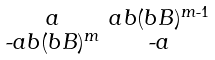<formula> <loc_0><loc_0><loc_500><loc_500>\begin{smallmatrix} a & a b ( b B ) ^ { m \text {-} 1 } \\ \text {-} a b ( b B ) ^ { m } & \text {-} a \end{smallmatrix}</formula> 